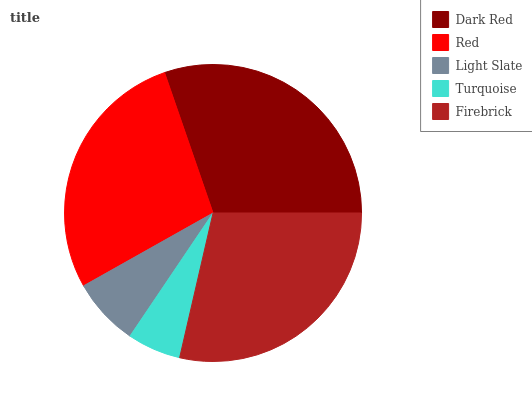Is Turquoise the minimum?
Answer yes or no. Yes. Is Dark Red the maximum?
Answer yes or no. Yes. Is Red the minimum?
Answer yes or no. No. Is Red the maximum?
Answer yes or no. No. Is Dark Red greater than Red?
Answer yes or no. Yes. Is Red less than Dark Red?
Answer yes or no. Yes. Is Red greater than Dark Red?
Answer yes or no. No. Is Dark Red less than Red?
Answer yes or no. No. Is Red the high median?
Answer yes or no. Yes. Is Red the low median?
Answer yes or no. Yes. Is Dark Red the high median?
Answer yes or no. No. Is Firebrick the low median?
Answer yes or no. No. 